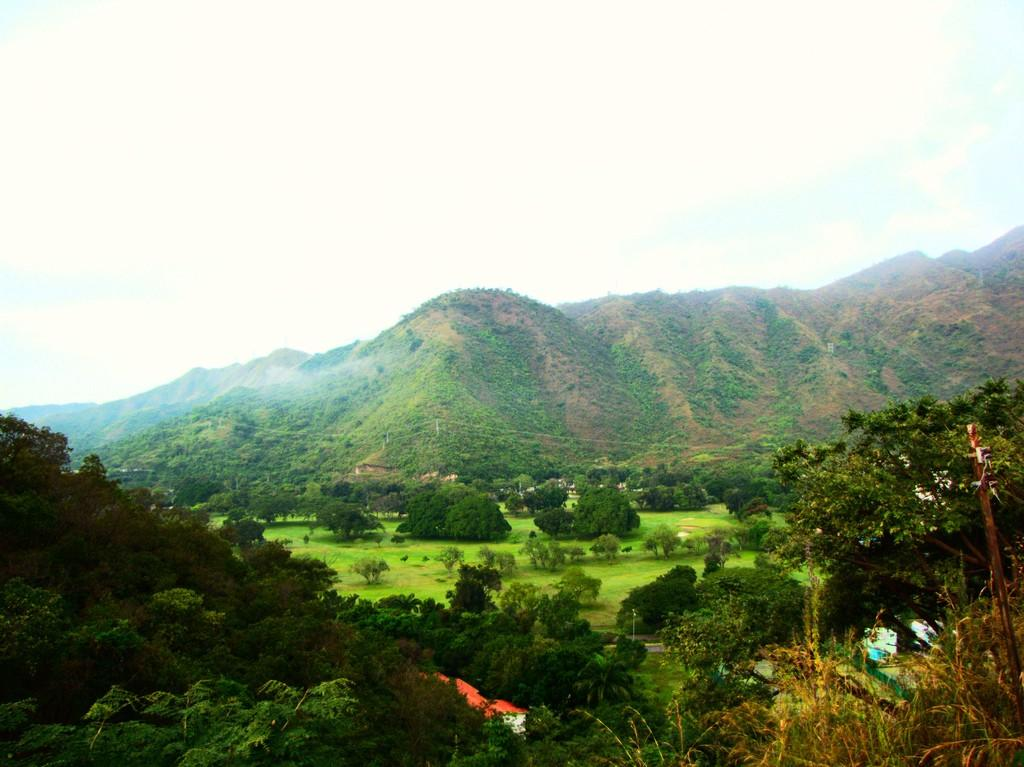What type of vegetation is present in the image? There are trees in the image. What else can be seen on the ground in the image? There is grass in the image. Where is the grass located in the image? The grass is located at the right bottom of the image. What can be seen in the distance in the image? There are hills visible in the background of the image. What is visible above the hills in the image? The sky is visible in the background of the image. How many bones are visible in the image? There are no bones present in the image. What type of event is taking place in the image? There is no event depicted in the image; it shows a natural landscape with trees, grass, hills, and the sky. 